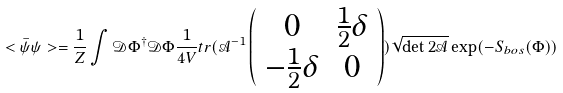<formula> <loc_0><loc_0><loc_500><loc_500>< \bar { \psi } \psi > = \frac { 1 } { Z } \int \mathcal { D } \Phi ^ { \dagger } \mathcal { D } \Phi \frac { 1 } { 4 V } t r ( \mathcal { A } ^ { - 1 } \left ( \begin{array} { c c } 0 & \frac { 1 } { 2 } \delta \\ - \frac { 1 } { 2 } \delta & 0 \\ \end{array} \right ) ) \sqrt { \det 2 \mathcal { A } } \exp ( - S _ { b o s } ( \Phi ) )</formula> 